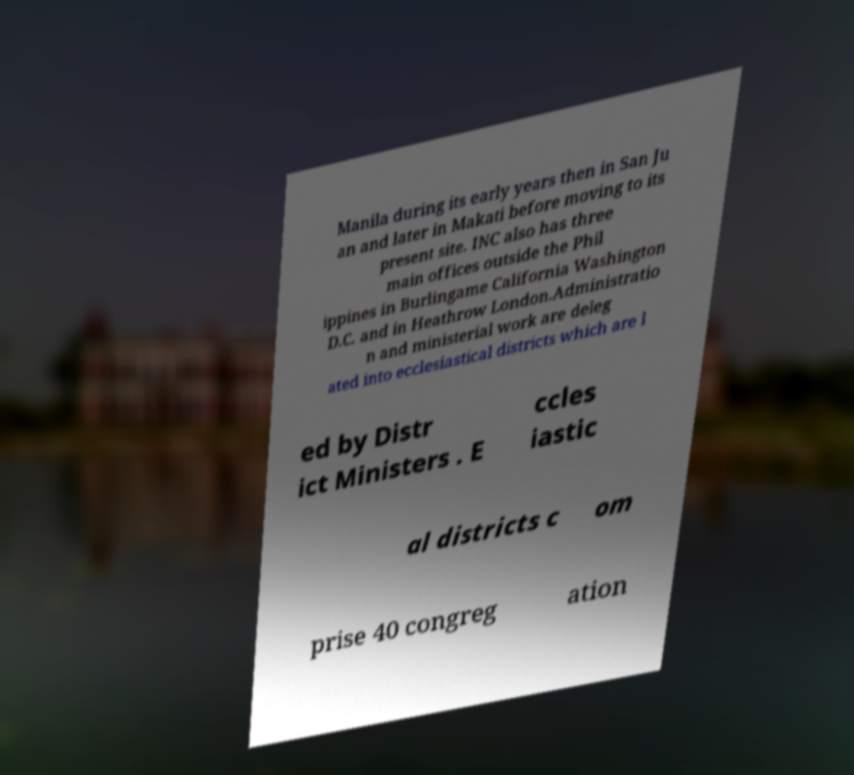There's text embedded in this image that I need extracted. Can you transcribe it verbatim? Manila during its early years then in San Ju an and later in Makati before moving to its present site. INC also has three main offices outside the Phil ippines in Burlingame California Washington D.C. and in Heathrow London.Administratio n and ministerial work are deleg ated into ecclesiastical districts which are l ed by Distr ict Ministers . E ccles iastic al districts c om prise 40 congreg ation 